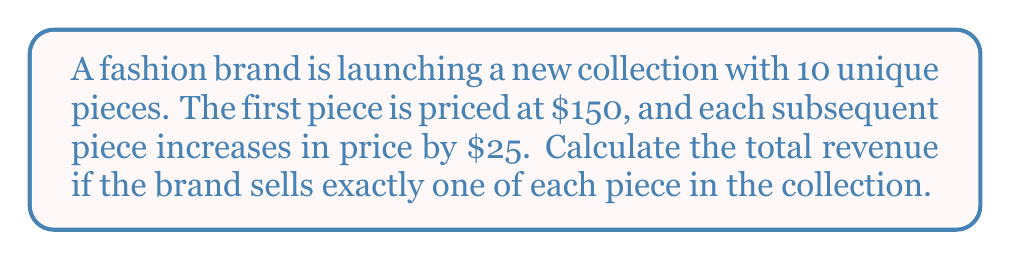Solve this math problem. To solve this problem, we need to use the formula for the sum of an arithmetic sequence:

$$S_n = \frac{n}{2}(a_1 + a_n)$$

Where:
$S_n$ is the sum of the sequence
$n$ is the number of terms
$a_1$ is the first term
$a_n$ is the last term

Step 1: Identify the given information
- Number of pieces (n) = 10
- Price of first piece ($a_1$) = $150
- Price increase per piece (d) = $25

Step 2: Calculate the price of the last piece ($a_n$)
$a_n = a_1 + (n-1)d$
$a_n = 150 + (10-1)25 = 150 + 225 = 375$

Step 3: Apply the formula for the sum of an arithmetic sequence
$$S_{10} = \frac{10}{2}(150 + 375) = 5(525) = 2,625$$

Therefore, the total revenue from selling one of each piece in the collection is $2,625.
Answer: $2,625 